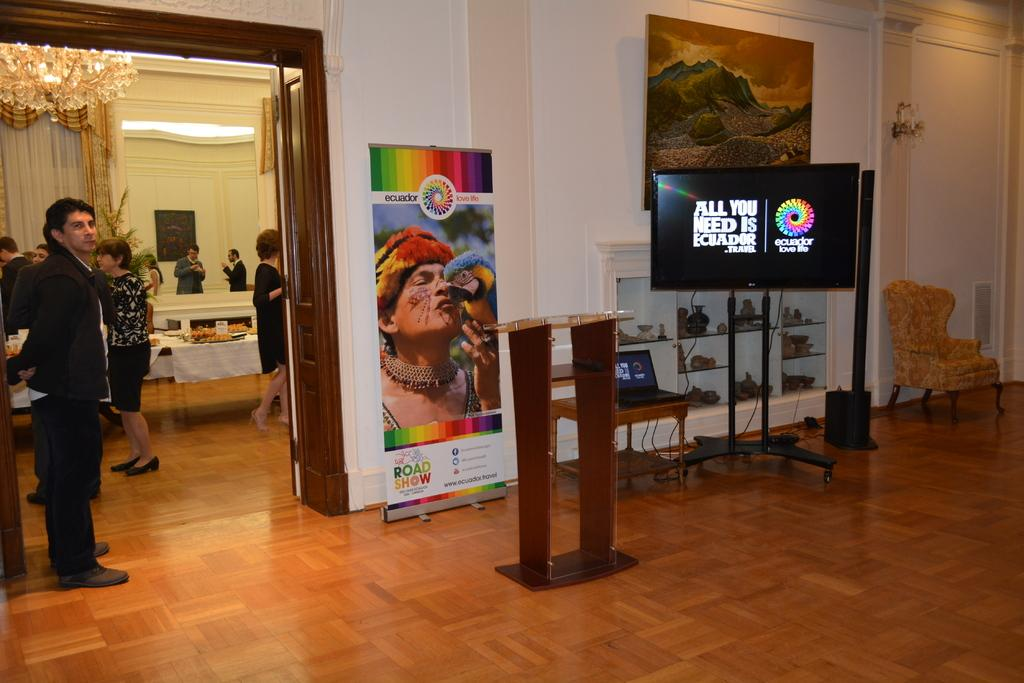<image>
Create a compact narrative representing the image presented. A television displays All you need is Ecuador at an event. 